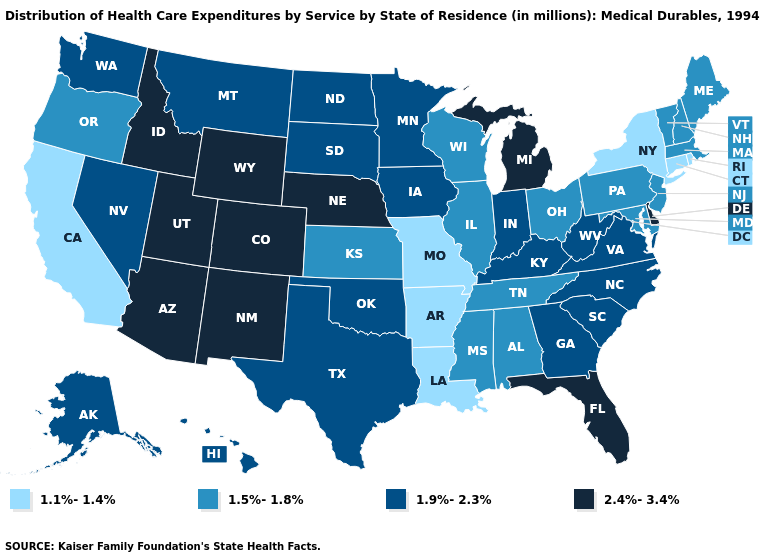What is the value of Maine?
Answer briefly. 1.5%-1.8%. Name the states that have a value in the range 1.5%-1.8%?
Concise answer only. Alabama, Illinois, Kansas, Maine, Maryland, Massachusetts, Mississippi, New Hampshire, New Jersey, Ohio, Oregon, Pennsylvania, Tennessee, Vermont, Wisconsin. What is the value of North Carolina?
Keep it brief. 1.9%-2.3%. Does Missouri have the lowest value in the USA?
Keep it brief. Yes. What is the value of New Mexico?
Be succinct. 2.4%-3.4%. What is the lowest value in the West?
Give a very brief answer. 1.1%-1.4%. Among the states that border Vermont , which have the lowest value?
Give a very brief answer. New York. Among the states that border Washington , does Idaho have the highest value?
Give a very brief answer. Yes. Name the states that have a value in the range 1.5%-1.8%?
Answer briefly. Alabama, Illinois, Kansas, Maine, Maryland, Massachusetts, Mississippi, New Hampshire, New Jersey, Ohio, Oregon, Pennsylvania, Tennessee, Vermont, Wisconsin. What is the highest value in the USA?
Concise answer only. 2.4%-3.4%. What is the value of North Dakota?
Be succinct. 1.9%-2.3%. Name the states that have a value in the range 1.9%-2.3%?
Give a very brief answer. Alaska, Georgia, Hawaii, Indiana, Iowa, Kentucky, Minnesota, Montana, Nevada, North Carolina, North Dakota, Oklahoma, South Carolina, South Dakota, Texas, Virginia, Washington, West Virginia. Among the states that border Nebraska , does Kansas have the lowest value?
Give a very brief answer. No. What is the lowest value in states that border Nebraska?
Short answer required. 1.1%-1.4%. Name the states that have a value in the range 1.5%-1.8%?
Answer briefly. Alabama, Illinois, Kansas, Maine, Maryland, Massachusetts, Mississippi, New Hampshire, New Jersey, Ohio, Oregon, Pennsylvania, Tennessee, Vermont, Wisconsin. 